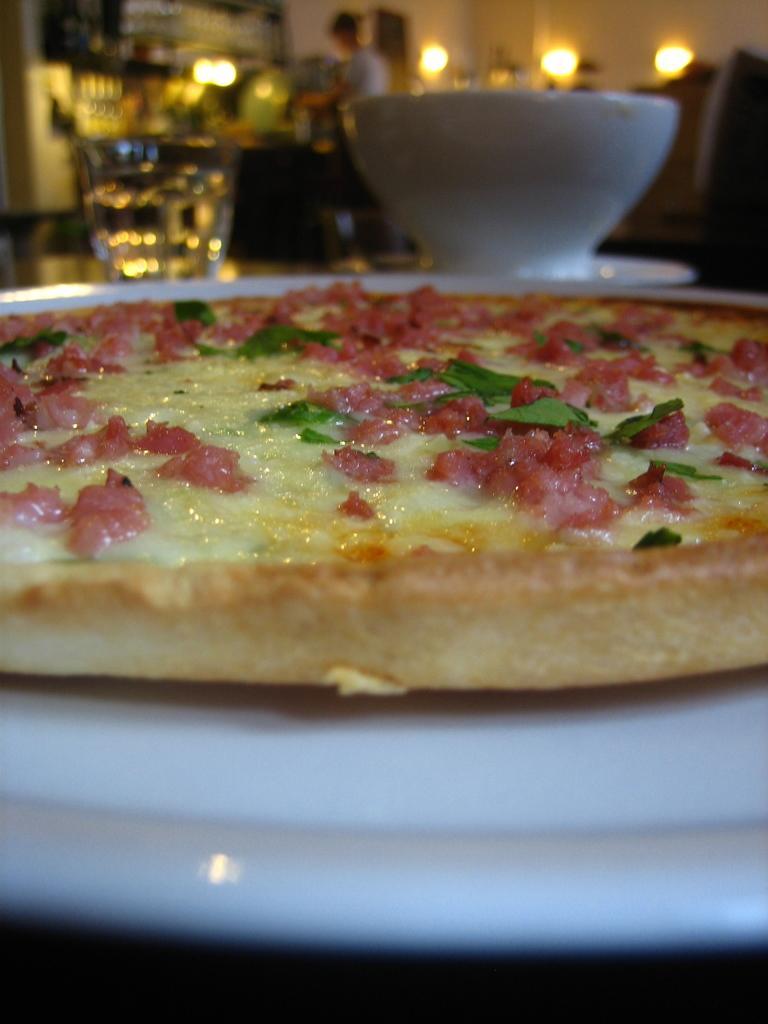Could you give a brief overview of what you see in this image? In the picture I can see a pizza which is placed on a plate and there is a bowl and a glass of water in front of it and there is a person and few lights in the background. 